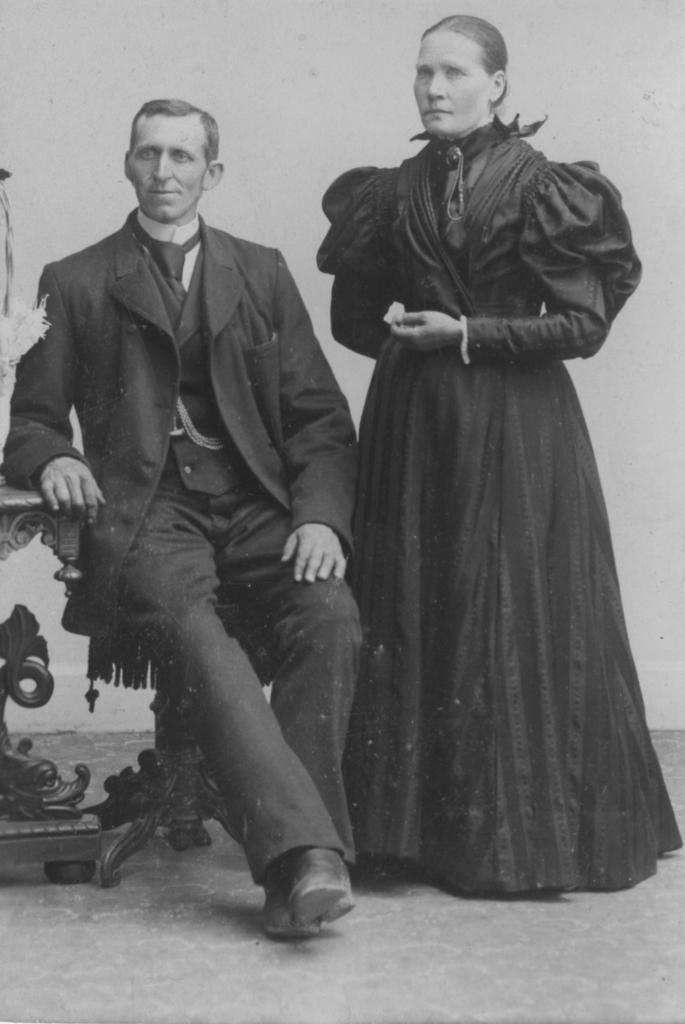In one or two sentences, can you explain what this image depicts? In this image I can see two people and I can see one person with the blazer. Among two people one person is sitting. To the left I can see the table. In the back I can see the wall. And this is a black and white image. 